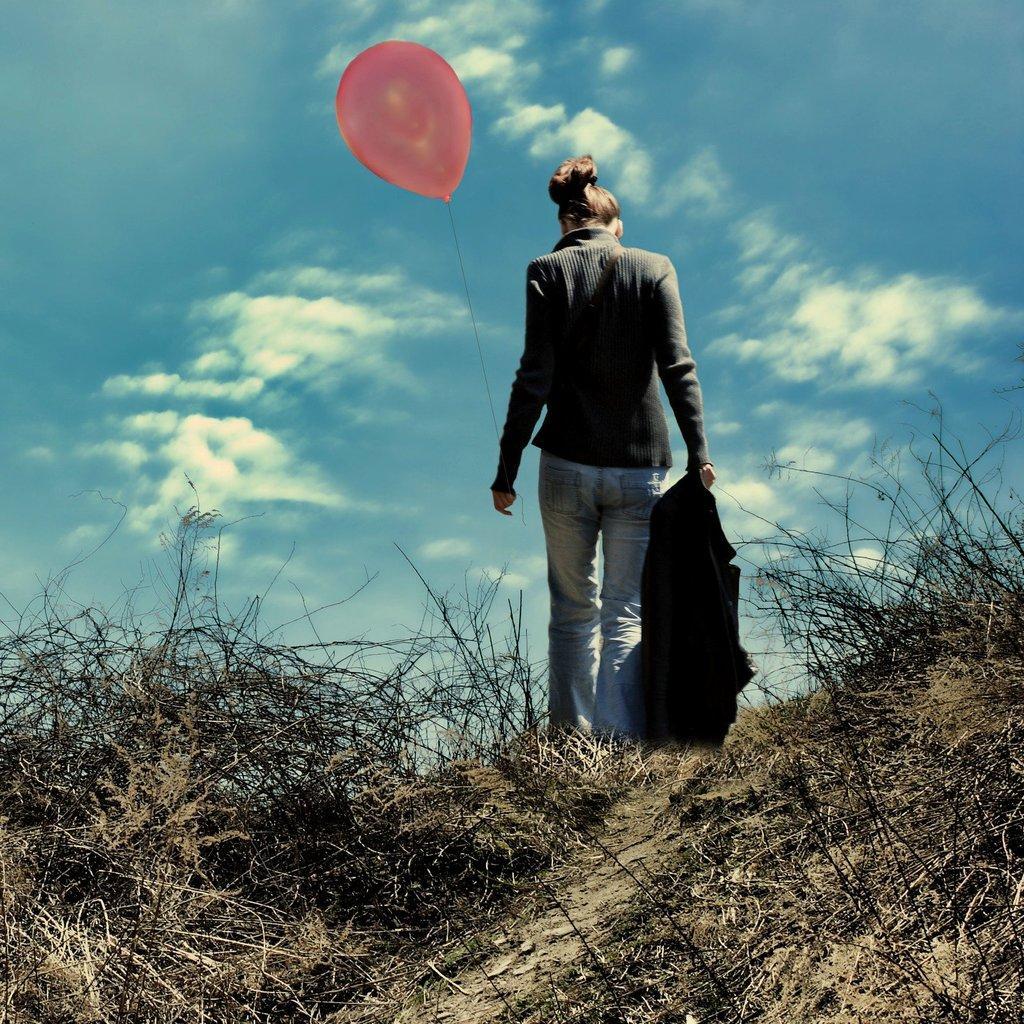Could you give a brief overview of what you see in this image? In this picture we can see woman carrying jacket in one hand and balloon in other hand and walking through the path with grass and above there is sky with clouds. 